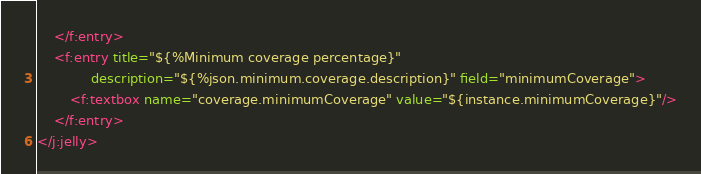Convert code to text. <code><loc_0><loc_0><loc_500><loc_500><_XML_>    </f:entry>
    <f:entry title="${%Minimum coverage percentage}"
             description="${%json.minimum.coverage.description}" field="minimumCoverage">
        <f:textbox name="coverage.minimumCoverage" value="${instance.minimumCoverage}"/>
    </f:entry>
</j:jelly></code> 